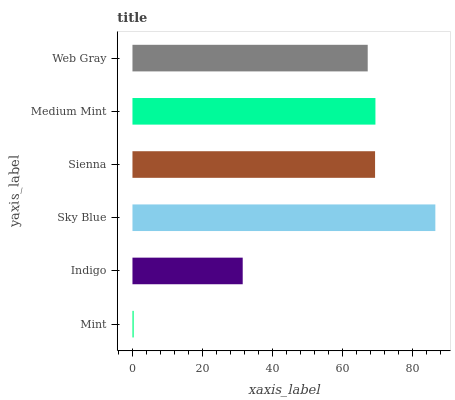Is Mint the minimum?
Answer yes or no. Yes. Is Sky Blue the maximum?
Answer yes or no. Yes. Is Indigo the minimum?
Answer yes or no. No. Is Indigo the maximum?
Answer yes or no. No. Is Indigo greater than Mint?
Answer yes or no. Yes. Is Mint less than Indigo?
Answer yes or no. Yes. Is Mint greater than Indigo?
Answer yes or no. No. Is Indigo less than Mint?
Answer yes or no. No. Is Sienna the high median?
Answer yes or no. Yes. Is Web Gray the low median?
Answer yes or no. Yes. Is Web Gray the high median?
Answer yes or no. No. Is Indigo the low median?
Answer yes or no. No. 